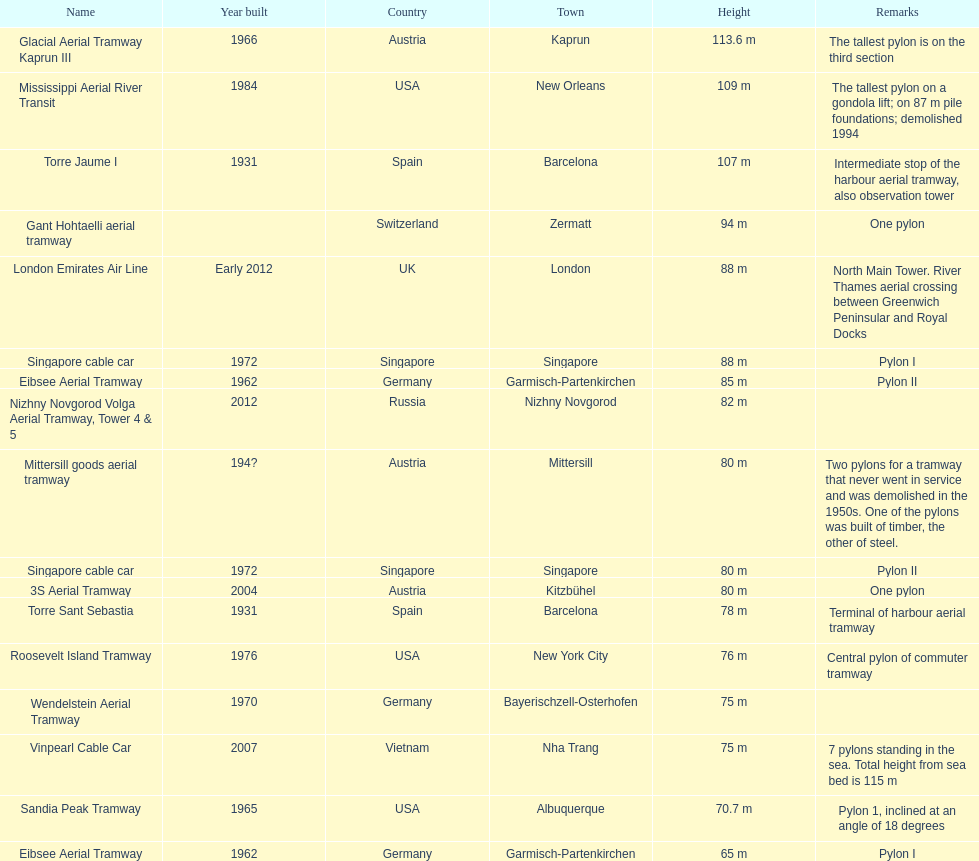In what year was germany's final pylon constructed? 1970. 